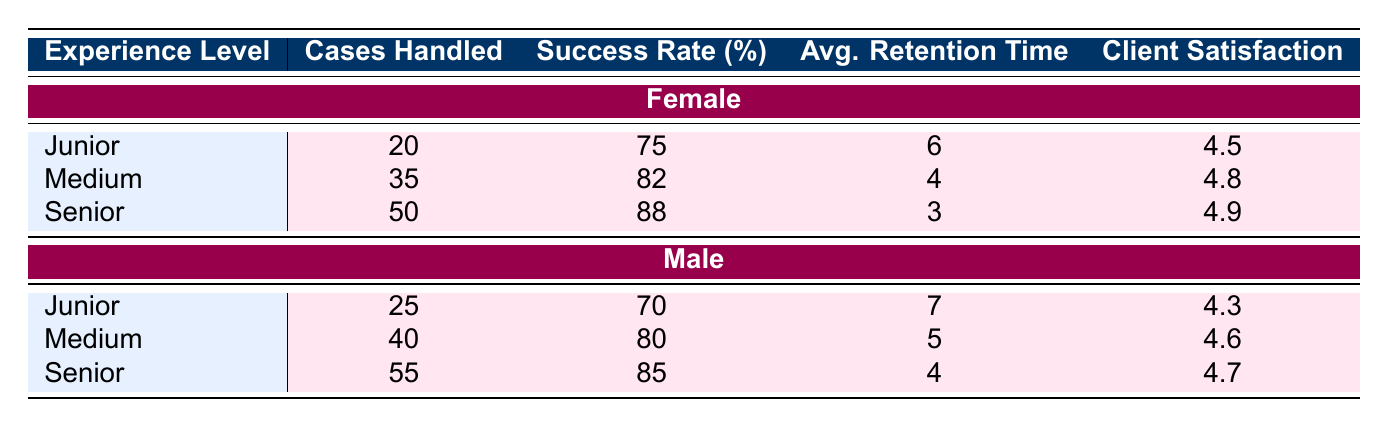What is the success rate for Female Senior staff? The success rate for Female Senior staff is found in the table under the Female section. It is listed as 88%.
Answer: 88% How many cases did Male Junior staff handle? Referring to the Male section in the Junior row of the table, it shows that Male Junior staff handled 25 cases.
Answer: 25 Which gender has a higher average client satisfaction score in the Medium experience level? The table shows that Female Medium staff have a client satisfaction score of 4.8 and Male Medium staff have a score of 4.6. Since 4.8 is greater than 4.6, Female Medium staff have a higher average client satisfaction score.
Answer: Female What is the average retention time for Female staff across all experience levels? To find the average retention time, we sum the average retention times for Female staff: 6 (Junior) + 4 (Medium) + 3 (Senior) = 13. Then, we divide by the number of experience levels (3), giving us 13/3 = 4.33.
Answer: 4.33 Does the success rate for Male Junior staff exceed 72%? According to the table, Male Junior staff have a success rate of 70%. Since 70% is less than 72%, the answer is no.
Answer: No What is the difference in the number of cases handled between Male and Female Senior staff? Female Senior staff handled 50 cases, while Male Senior staff handled 55 cases. The difference is 55 (Male) - 50 (Female) = 5.
Answer: 5 What is the combined success rate for Female Junior and Medium staff? The success rates for Female Junior and Medium staff are 75% and 82%, respectively. The combined success rate can be found by averaging these two rates: (75 + 82) / 2 = 78.5%.
Answer: 78.5% Which group handled the most cases overall? Female Senior staff handled 50 cases, Male Senior staff handled 55 cases, Female Medium staff handled 35 cases, Male Medium staff handled 40 cases, Female Junior staff handled 20 cases, and Male Junior handled 25 cases. Adding those, Male staff handled 55 + 40 + 25 = 120 and Female staff handled 50 + 35 + 20 = 105. Since 120 is greater than 105, Male staff handled the most cases overall.
Answer: Male staff 